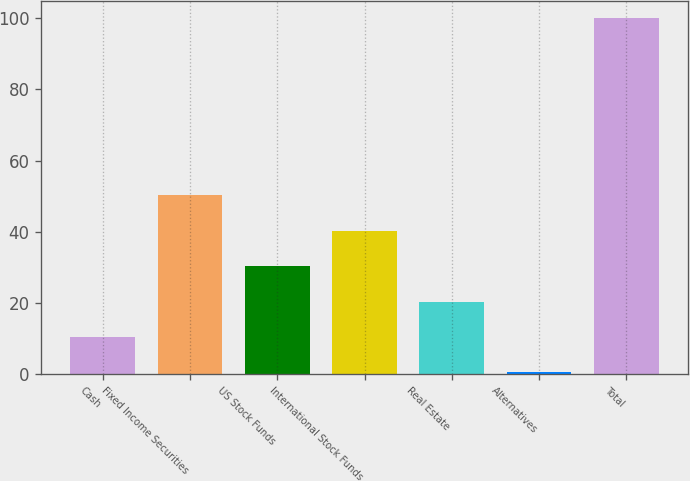<chart> <loc_0><loc_0><loc_500><loc_500><bar_chart><fcel>Cash<fcel>Fixed Income Securities<fcel>US Stock Funds<fcel>International Stock Funds<fcel>Real Estate<fcel>Alternatives<fcel>Total<nl><fcel>10.36<fcel>50.2<fcel>30.28<fcel>40.24<fcel>20.32<fcel>0.4<fcel>100<nl></chart> 